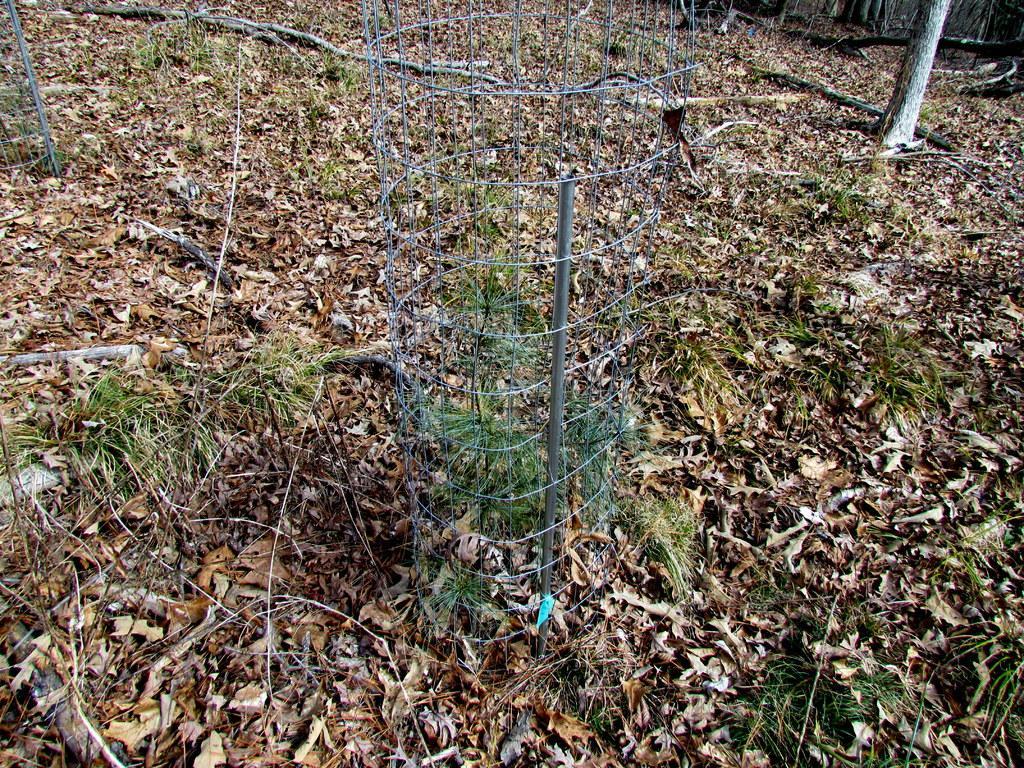In one or two sentences, can you explain what this image depicts? In this image we can see some plants, grass, trees, trunks, also we can see a fence, and some leaves on the ground. 